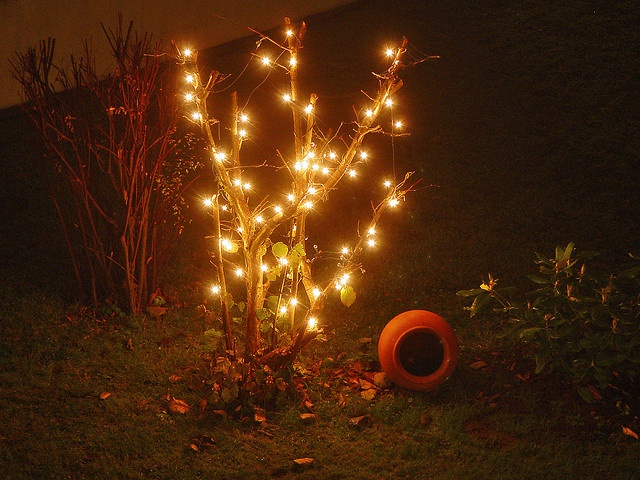Describe the objects in this image and their specific colors. I can see a vase in black, maroon, brown, and red tones in this image. 